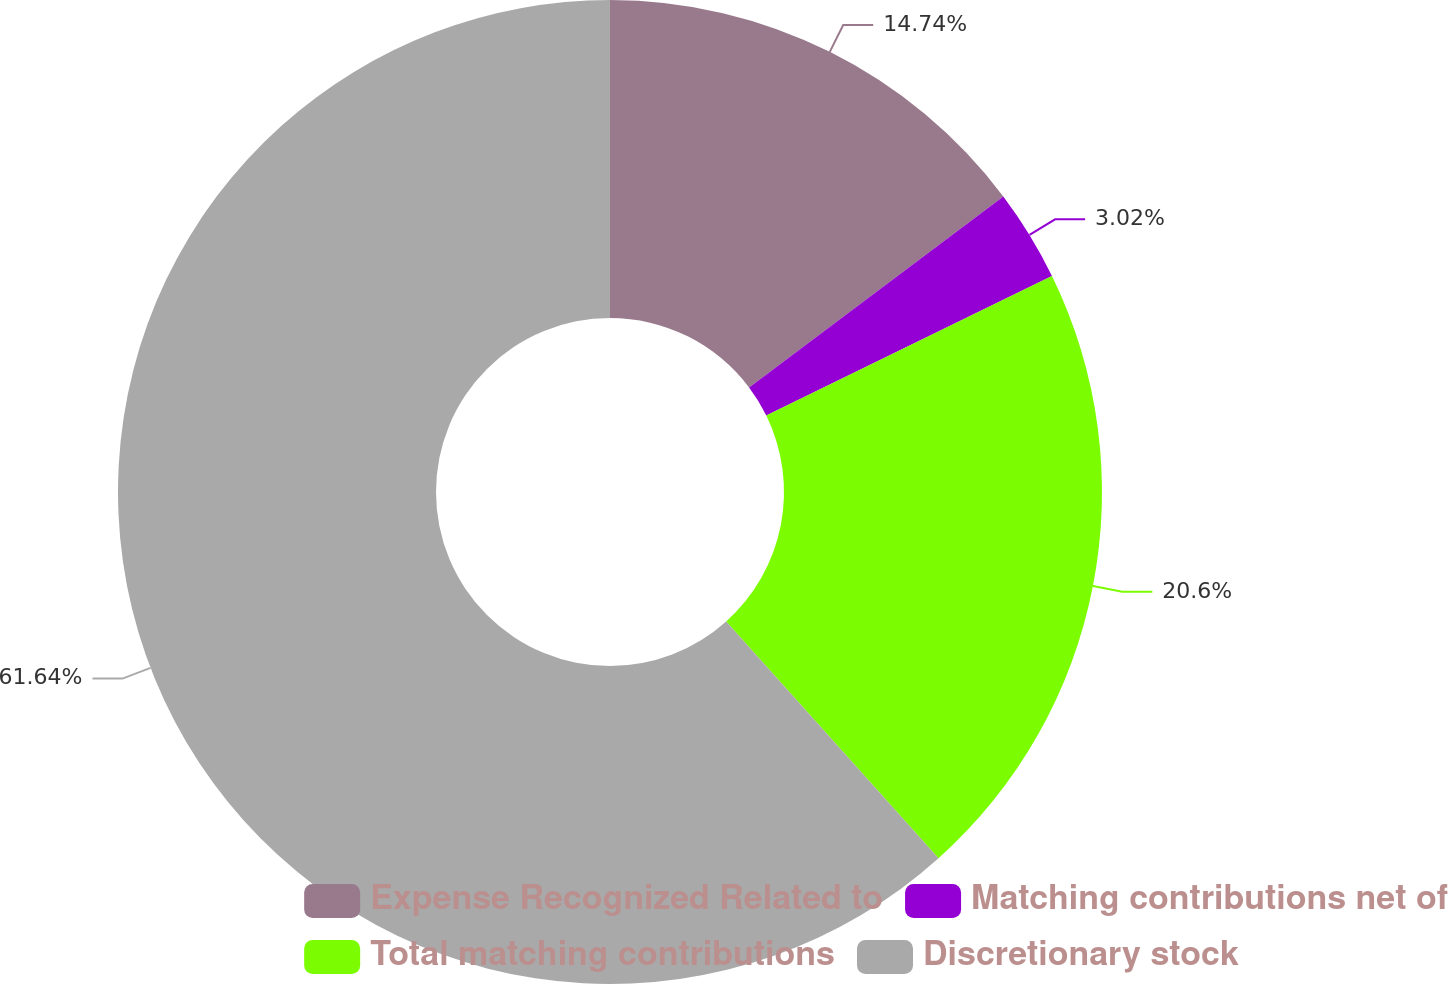<chart> <loc_0><loc_0><loc_500><loc_500><pie_chart><fcel>Expense Recognized Related to<fcel>Matching contributions net of<fcel>Total matching contributions<fcel>Discretionary stock<nl><fcel>14.74%<fcel>3.02%<fcel>20.6%<fcel>61.63%<nl></chart> 